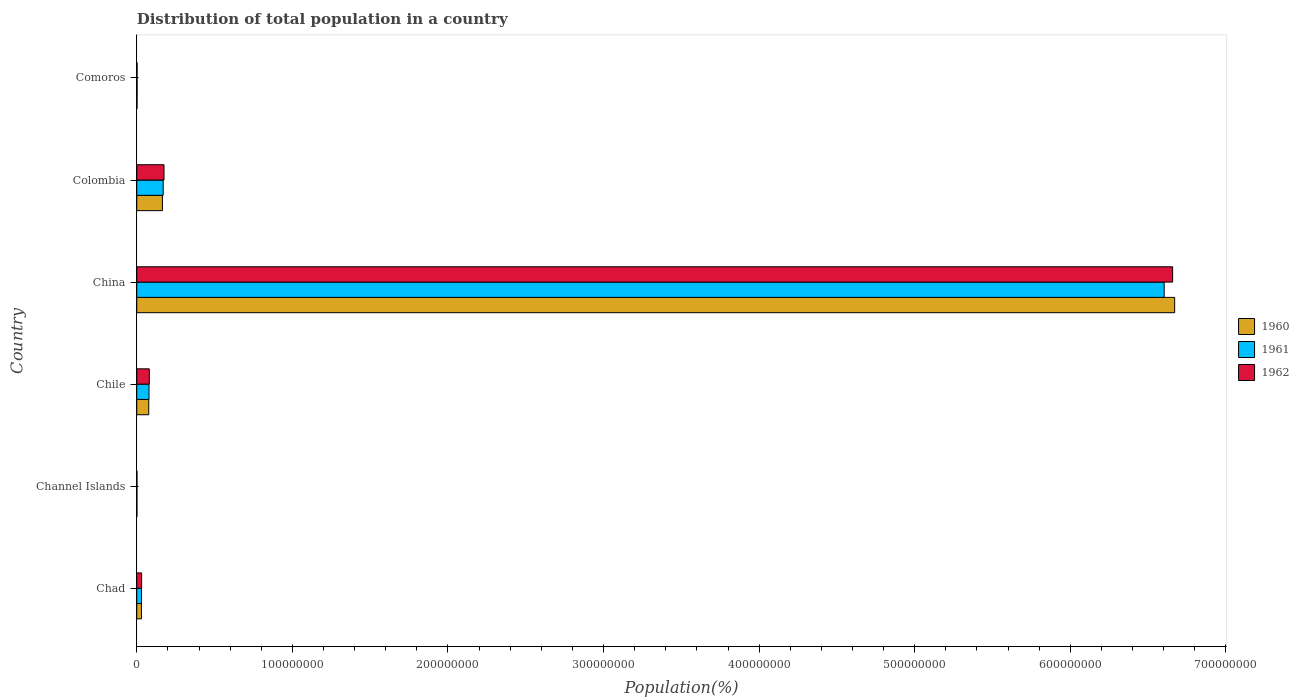Are the number of bars per tick equal to the number of legend labels?
Ensure brevity in your answer.  Yes. What is the label of the 2nd group of bars from the top?
Make the answer very short. Colombia. What is the population of in 1961 in Chad?
Offer a terse response. 3.06e+06. Across all countries, what is the maximum population of in 1960?
Give a very brief answer. 6.67e+08. Across all countries, what is the minimum population of in 1960?
Provide a succinct answer. 1.09e+05. In which country was the population of in 1962 maximum?
Offer a terse response. China. In which country was the population of in 1962 minimum?
Your answer should be compact. Channel Islands. What is the total population of in 1961 in the graph?
Provide a succinct answer. 6.89e+08. What is the difference between the population of in 1962 in Colombia and that in Comoros?
Provide a succinct answer. 1.73e+07. What is the difference between the population of in 1961 in Chile and the population of in 1962 in Channel Islands?
Keep it short and to the point. 7.76e+06. What is the average population of in 1962 per country?
Your answer should be very brief. 1.16e+08. What is the difference between the population of in 1962 and population of in 1960 in Chile?
Your answer should be very brief. 3.58e+05. In how many countries, is the population of in 1961 greater than 400000000 %?
Your response must be concise. 1. What is the ratio of the population of in 1961 in Chile to that in China?
Offer a terse response. 0.01. Is the population of in 1961 in Chile less than that in Comoros?
Make the answer very short. No. What is the difference between the highest and the second highest population of in 1960?
Provide a succinct answer. 6.51e+08. What is the difference between the highest and the lowest population of in 1960?
Make the answer very short. 6.67e+08. Is the sum of the population of in 1960 in Channel Islands and China greater than the maximum population of in 1962 across all countries?
Keep it short and to the point. Yes. What does the 1st bar from the bottom in Chad represents?
Make the answer very short. 1960. Is it the case that in every country, the sum of the population of in 1961 and population of in 1962 is greater than the population of in 1960?
Give a very brief answer. Yes. What is the difference between two consecutive major ticks on the X-axis?
Keep it short and to the point. 1.00e+08. How are the legend labels stacked?
Provide a succinct answer. Vertical. What is the title of the graph?
Ensure brevity in your answer.  Distribution of total population in a country. Does "1971" appear as one of the legend labels in the graph?
Ensure brevity in your answer.  No. What is the label or title of the X-axis?
Ensure brevity in your answer.  Population(%). What is the Population(%) in 1960 in Chad?
Provide a succinct answer. 3.00e+06. What is the Population(%) of 1961 in Chad?
Provide a short and direct response. 3.06e+06. What is the Population(%) of 1962 in Chad?
Keep it short and to the point. 3.12e+06. What is the Population(%) in 1960 in Channel Islands?
Provide a short and direct response. 1.09e+05. What is the Population(%) of 1961 in Channel Islands?
Offer a terse response. 1.10e+05. What is the Population(%) of 1962 in Channel Islands?
Your answer should be very brief. 1.11e+05. What is the Population(%) of 1960 in Chile?
Your answer should be compact. 7.70e+06. What is the Population(%) in 1961 in Chile?
Provide a succinct answer. 7.87e+06. What is the Population(%) of 1962 in Chile?
Offer a terse response. 8.05e+06. What is the Population(%) in 1960 in China?
Provide a succinct answer. 6.67e+08. What is the Population(%) in 1961 in China?
Your response must be concise. 6.60e+08. What is the Population(%) of 1962 in China?
Provide a short and direct response. 6.66e+08. What is the Population(%) of 1960 in Colombia?
Your answer should be compact. 1.65e+07. What is the Population(%) of 1961 in Colombia?
Provide a short and direct response. 1.70e+07. What is the Population(%) of 1962 in Colombia?
Ensure brevity in your answer.  1.75e+07. What is the Population(%) of 1960 in Comoros?
Provide a succinct answer. 1.89e+05. What is the Population(%) of 1961 in Comoros?
Provide a succinct answer. 1.92e+05. What is the Population(%) of 1962 in Comoros?
Ensure brevity in your answer.  1.95e+05. Across all countries, what is the maximum Population(%) of 1960?
Ensure brevity in your answer.  6.67e+08. Across all countries, what is the maximum Population(%) in 1961?
Provide a succinct answer. 6.60e+08. Across all countries, what is the maximum Population(%) in 1962?
Provide a succinct answer. 6.66e+08. Across all countries, what is the minimum Population(%) of 1960?
Ensure brevity in your answer.  1.09e+05. Across all countries, what is the minimum Population(%) of 1961?
Your answer should be compact. 1.10e+05. Across all countries, what is the minimum Population(%) in 1962?
Your response must be concise. 1.11e+05. What is the total Population(%) of 1960 in the graph?
Your response must be concise. 6.95e+08. What is the total Population(%) of 1961 in the graph?
Keep it short and to the point. 6.89e+08. What is the total Population(%) of 1962 in the graph?
Ensure brevity in your answer.  6.95e+08. What is the difference between the Population(%) of 1960 in Chad and that in Channel Islands?
Ensure brevity in your answer.  2.89e+06. What is the difference between the Population(%) of 1961 in Chad and that in Channel Islands?
Make the answer very short. 2.95e+06. What is the difference between the Population(%) of 1962 in Chad and that in Channel Islands?
Your answer should be compact. 3.01e+06. What is the difference between the Population(%) of 1960 in Chad and that in Chile?
Your answer should be very brief. -4.69e+06. What is the difference between the Population(%) of 1961 in Chad and that in Chile?
Your response must be concise. -4.81e+06. What is the difference between the Population(%) in 1962 in Chad and that in Chile?
Provide a short and direct response. -4.93e+06. What is the difference between the Population(%) of 1960 in Chad and that in China?
Your answer should be compact. -6.64e+08. What is the difference between the Population(%) in 1961 in Chad and that in China?
Offer a very short reply. -6.57e+08. What is the difference between the Population(%) of 1962 in Chad and that in China?
Your answer should be compact. -6.63e+08. What is the difference between the Population(%) in 1960 in Chad and that in Colombia?
Provide a succinct answer. -1.35e+07. What is the difference between the Population(%) in 1961 in Chad and that in Colombia?
Ensure brevity in your answer.  -1.39e+07. What is the difference between the Population(%) in 1962 in Chad and that in Colombia?
Provide a succinct answer. -1.44e+07. What is the difference between the Population(%) of 1960 in Chad and that in Comoros?
Provide a short and direct response. 2.81e+06. What is the difference between the Population(%) of 1961 in Chad and that in Comoros?
Provide a short and direct response. 2.87e+06. What is the difference between the Population(%) of 1962 in Chad and that in Comoros?
Your answer should be compact. 2.93e+06. What is the difference between the Population(%) in 1960 in Channel Islands and that in Chile?
Your response must be concise. -7.59e+06. What is the difference between the Population(%) of 1961 in Channel Islands and that in Chile?
Offer a terse response. -7.76e+06. What is the difference between the Population(%) of 1962 in Channel Islands and that in Chile?
Ensure brevity in your answer.  -7.94e+06. What is the difference between the Population(%) of 1960 in Channel Islands and that in China?
Make the answer very short. -6.67e+08. What is the difference between the Population(%) of 1961 in Channel Islands and that in China?
Provide a succinct answer. -6.60e+08. What is the difference between the Population(%) of 1962 in Channel Islands and that in China?
Keep it short and to the point. -6.66e+08. What is the difference between the Population(%) in 1960 in Channel Islands and that in Colombia?
Provide a short and direct response. -1.64e+07. What is the difference between the Population(%) in 1961 in Channel Islands and that in Colombia?
Give a very brief answer. -1.69e+07. What is the difference between the Population(%) in 1962 in Channel Islands and that in Colombia?
Offer a very short reply. -1.74e+07. What is the difference between the Population(%) of 1960 in Channel Islands and that in Comoros?
Make the answer very short. -7.93e+04. What is the difference between the Population(%) in 1961 in Channel Islands and that in Comoros?
Your response must be concise. -8.14e+04. What is the difference between the Population(%) of 1962 in Channel Islands and that in Comoros?
Make the answer very short. -8.35e+04. What is the difference between the Population(%) of 1960 in Chile and that in China?
Offer a very short reply. -6.59e+08. What is the difference between the Population(%) in 1961 in Chile and that in China?
Ensure brevity in your answer.  -6.52e+08. What is the difference between the Population(%) of 1962 in Chile and that in China?
Your answer should be very brief. -6.58e+08. What is the difference between the Population(%) of 1960 in Chile and that in Colombia?
Your response must be concise. -8.78e+06. What is the difference between the Population(%) of 1961 in Chile and that in Colombia?
Provide a succinct answer. -9.11e+06. What is the difference between the Population(%) of 1962 in Chile and that in Colombia?
Offer a very short reply. -9.45e+06. What is the difference between the Population(%) in 1960 in Chile and that in Comoros?
Your answer should be very brief. 7.51e+06. What is the difference between the Population(%) in 1961 in Chile and that in Comoros?
Make the answer very short. 7.68e+06. What is the difference between the Population(%) in 1962 in Chile and that in Comoros?
Your answer should be compact. 7.86e+06. What is the difference between the Population(%) of 1960 in China and that in Colombia?
Offer a terse response. 6.51e+08. What is the difference between the Population(%) of 1961 in China and that in Colombia?
Keep it short and to the point. 6.43e+08. What is the difference between the Population(%) of 1962 in China and that in Colombia?
Keep it short and to the point. 6.48e+08. What is the difference between the Population(%) in 1960 in China and that in Comoros?
Your response must be concise. 6.67e+08. What is the difference between the Population(%) of 1961 in China and that in Comoros?
Offer a very short reply. 6.60e+08. What is the difference between the Population(%) of 1962 in China and that in Comoros?
Make the answer very short. 6.66e+08. What is the difference between the Population(%) of 1960 in Colombia and that in Comoros?
Offer a very short reply. 1.63e+07. What is the difference between the Population(%) of 1961 in Colombia and that in Comoros?
Keep it short and to the point. 1.68e+07. What is the difference between the Population(%) in 1962 in Colombia and that in Comoros?
Make the answer very short. 1.73e+07. What is the difference between the Population(%) in 1960 in Chad and the Population(%) in 1961 in Channel Islands?
Your response must be concise. 2.89e+06. What is the difference between the Population(%) of 1960 in Chad and the Population(%) of 1962 in Channel Islands?
Your answer should be very brief. 2.89e+06. What is the difference between the Population(%) of 1961 in Chad and the Population(%) of 1962 in Channel Islands?
Provide a short and direct response. 2.95e+06. What is the difference between the Population(%) of 1960 in Chad and the Population(%) of 1961 in Chile?
Your response must be concise. -4.87e+06. What is the difference between the Population(%) of 1960 in Chad and the Population(%) of 1962 in Chile?
Ensure brevity in your answer.  -5.05e+06. What is the difference between the Population(%) in 1961 in Chad and the Population(%) in 1962 in Chile?
Offer a terse response. -4.99e+06. What is the difference between the Population(%) of 1960 in Chad and the Population(%) of 1961 in China?
Ensure brevity in your answer.  -6.57e+08. What is the difference between the Population(%) of 1960 in Chad and the Population(%) of 1962 in China?
Give a very brief answer. -6.63e+08. What is the difference between the Population(%) of 1961 in Chad and the Population(%) of 1962 in China?
Make the answer very short. -6.63e+08. What is the difference between the Population(%) in 1960 in Chad and the Population(%) in 1961 in Colombia?
Provide a succinct answer. -1.40e+07. What is the difference between the Population(%) in 1960 in Chad and the Population(%) in 1962 in Colombia?
Make the answer very short. -1.45e+07. What is the difference between the Population(%) in 1961 in Chad and the Population(%) in 1962 in Colombia?
Keep it short and to the point. -1.44e+07. What is the difference between the Population(%) of 1960 in Chad and the Population(%) of 1961 in Comoros?
Your response must be concise. 2.81e+06. What is the difference between the Population(%) in 1960 in Chad and the Population(%) in 1962 in Comoros?
Your answer should be very brief. 2.81e+06. What is the difference between the Population(%) of 1961 in Chad and the Population(%) of 1962 in Comoros?
Keep it short and to the point. 2.87e+06. What is the difference between the Population(%) of 1960 in Channel Islands and the Population(%) of 1961 in Chile?
Provide a succinct answer. -7.76e+06. What is the difference between the Population(%) in 1960 in Channel Islands and the Population(%) in 1962 in Chile?
Offer a terse response. -7.94e+06. What is the difference between the Population(%) of 1961 in Channel Islands and the Population(%) of 1962 in Chile?
Your response must be concise. -7.94e+06. What is the difference between the Population(%) of 1960 in Channel Islands and the Population(%) of 1961 in China?
Provide a succinct answer. -6.60e+08. What is the difference between the Population(%) in 1960 in Channel Islands and the Population(%) in 1962 in China?
Make the answer very short. -6.66e+08. What is the difference between the Population(%) in 1961 in Channel Islands and the Population(%) in 1962 in China?
Keep it short and to the point. -6.66e+08. What is the difference between the Population(%) of 1960 in Channel Islands and the Population(%) of 1961 in Colombia?
Offer a terse response. -1.69e+07. What is the difference between the Population(%) in 1960 in Channel Islands and the Population(%) in 1962 in Colombia?
Ensure brevity in your answer.  -1.74e+07. What is the difference between the Population(%) of 1961 in Channel Islands and the Population(%) of 1962 in Colombia?
Ensure brevity in your answer.  -1.74e+07. What is the difference between the Population(%) of 1960 in Channel Islands and the Population(%) of 1961 in Comoros?
Provide a short and direct response. -8.24e+04. What is the difference between the Population(%) of 1960 in Channel Islands and the Population(%) of 1962 in Comoros?
Give a very brief answer. -8.55e+04. What is the difference between the Population(%) of 1961 in Channel Islands and the Population(%) of 1962 in Comoros?
Provide a short and direct response. -8.46e+04. What is the difference between the Population(%) of 1960 in Chile and the Population(%) of 1961 in China?
Make the answer very short. -6.53e+08. What is the difference between the Population(%) of 1960 in Chile and the Population(%) of 1962 in China?
Your answer should be compact. -6.58e+08. What is the difference between the Population(%) of 1961 in Chile and the Population(%) of 1962 in China?
Your answer should be very brief. -6.58e+08. What is the difference between the Population(%) in 1960 in Chile and the Population(%) in 1961 in Colombia?
Your answer should be very brief. -9.29e+06. What is the difference between the Population(%) of 1960 in Chile and the Population(%) of 1962 in Colombia?
Your response must be concise. -9.80e+06. What is the difference between the Population(%) in 1961 in Chile and the Population(%) in 1962 in Colombia?
Keep it short and to the point. -9.63e+06. What is the difference between the Population(%) of 1960 in Chile and the Population(%) of 1961 in Comoros?
Provide a short and direct response. 7.50e+06. What is the difference between the Population(%) in 1960 in Chile and the Population(%) in 1962 in Comoros?
Ensure brevity in your answer.  7.50e+06. What is the difference between the Population(%) of 1961 in Chile and the Population(%) of 1962 in Comoros?
Keep it short and to the point. 7.68e+06. What is the difference between the Population(%) in 1960 in China and the Population(%) in 1961 in Colombia?
Your response must be concise. 6.50e+08. What is the difference between the Population(%) of 1960 in China and the Population(%) of 1962 in Colombia?
Your answer should be compact. 6.50e+08. What is the difference between the Population(%) of 1961 in China and the Population(%) of 1962 in Colombia?
Your answer should be compact. 6.43e+08. What is the difference between the Population(%) of 1960 in China and the Population(%) of 1961 in Comoros?
Provide a succinct answer. 6.67e+08. What is the difference between the Population(%) of 1960 in China and the Population(%) of 1962 in Comoros?
Your response must be concise. 6.67e+08. What is the difference between the Population(%) in 1961 in China and the Population(%) in 1962 in Comoros?
Give a very brief answer. 6.60e+08. What is the difference between the Population(%) in 1960 in Colombia and the Population(%) in 1961 in Comoros?
Offer a terse response. 1.63e+07. What is the difference between the Population(%) in 1960 in Colombia and the Population(%) in 1962 in Comoros?
Your answer should be very brief. 1.63e+07. What is the difference between the Population(%) of 1961 in Colombia and the Population(%) of 1962 in Comoros?
Keep it short and to the point. 1.68e+07. What is the average Population(%) in 1960 per country?
Your answer should be compact. 1.16e+08. What is the average Population(%) in 1961 per country?
Your answer should be compact. 1.15e+08. What is the average Population(%) in 1962 per country?
Make the answer very short. 1.16e+08. What is the difference between the Population(%) in 1960 and Population(%) in 1961 in Chad?
Provide a short and direct response. -5.88e+04. What is the difference between the Population(%) of 1960 and Population(%) of 1962 in Chad?
Ensure brevity in your answer.  -1.20e+05. What is the difference between the Population(%) in 1961 and Population(%) in 1962 in Chad?
Offer a very short reply. -6.09e+04. What is the difference between the Population(%) in 1960 and Population(%) in 1961 in Channel Islands?
Your response must be concise. -980. What is the difference between the Population(%) in 1960 and Population(%) in 1962 in Channel Islands?
Offer a very short reply. -2044. What is the difference between the Population(%) of 1961 and Population(%) of 1962 in Channel Islands?
Offer a terse response. -1064. What is the difference between the Population(%) of 1960 and Population(%) of 1961 in Chile?
Make the answer very short. -1.78e+05. What is the difference between the Population(%) of 1960 and Population(%) of 1962 in Chile?
Ensure brevity in your answer.  -3.58e+05. What is the difference between the Population(%) in 1961 and Population(%) in 1962 in Chile?
Ensure brevity in your answer.  -1.81e+05. What is the difference between the Population(%) of 1960 and Population(%) of 1961 in China?
Offer a terse response. 6.74e+06. What is the difference between the Population(%) in 1960 and Population(%) in 1962 in China?
Provide a short and direct response. 1.30e+06. What is the difference between the Population(%) of 1961 and Population(%) of 1962 in China?
Keep it short and to the point. -5.44e+06. What is the difference between the Population(%) of 1960 and Population(%) of 1961 in Colombia?
Ensure brevity in your answer.  -5.02e+05. What is the difference between the Population(%) of 1960 and Population(%) of 1962 in Colombia?
Give a very brief answer. -1.02e+06. What is the difference between the Population(%) of 1961 and Population(%) of 1962 in Colombia?
Provide a short and direct response. -5.18e+05. What is the difference between the Population(%) in 1960 and Population(%) in 1961 in Comoros?
Offer a very short reply. -3096. What is the difference between the Population(%) in 1960 and Population(%) in 1962 in Comoros?
Your answer should be compact. -6228. What is the difference between the Population(%) of 1961 and Population(%) of 1962 in Comoros?
Keep it short and to the point. -3132. What is the ratio of the Population(%) in 1960 in Chad to that in Channel Islands?
Keep it short and to the point. 27.44. What is the ratio of the Population(%) in 1961 in Chad to that in Channel Islands?
Ensure brevity in your answer.  27.73. What is the ratio of the Population(%) of 1962 in Chad to that in Channel Islands?
Give a very brief answer. 28.01. What is the ratio of the Population(%) of 1960 in Chad to that in Chile?
Your answer should be compact. 0.39. What is the ratio of the Population(%) in 1961 in Chad to that in Chile?
Make the answer very short. 0.39. What is the ratio of the Population(%) of 1962 in Chad to that in Chile?
Offer a terse response. 0.39. What is the ratio of the Population(%) in 1960 in Chad to that in China?
Your answer should be very brief. 0. What is the ratio of the Population(%) in 1961 in Chad to that in China?
Keep it short and to the point. 0. What is the ratio of the Population(%) of 1962 in Chad to that in China?
Your answer should be very brief. 0. What is the ratio of the Population(%) of 1960 in Chad to that in Colombia?
Your answer should be compact. 0.18. What is the ratio of the Population(%) of 1961 in Chad to that in Colombia?
Offer a terse response. 0.18. What is the ratio of the Population(%) of 1962 in Chad to that in Colombia?
Ensure brevity in your answer.  0.18. What is the ratio of the Population(%) of 1960 in Chad to that in Comoros?
Your answer should be very brief. 15.91. What is the ratio of the Population(%) of 1961 in Chad to that in Comoros?
Your answer should be compact. 15.96. What is the ratio of the Population(%) of 1962 in Chad to that in Comoros?
Offer a very short reply. 16.02. What is the ratio of the Population(%) in 1960 in Channel Islands to that in Chile?
Give a very brief answer. 0.01. What is the ratio of the Population(%) in 1961 in Channel Islands to that in Chile?
Keep it short and to the point. 0.01. What is the ratio of the Population(%) in 1962 in Channel Islands to that in Chile?
Give a very brief answer. 0.01. What is the ratio of the Population(%) in 1960 in Channel Islands to that in Colombia?
Provide a succinct answer. 0.01. What is the ratio of the Population(%) in 1961 in Channel Islands to that in Colombia?
Ensure brevity in your answer.  0.01. What is the ratio of the Population(%) of 1962 in Channel Islands to that in Colombia?
Provide a short and direct response. 0.01. What is the ratio of the Population(%) of 1960 in Channel Islands to that in Comoros?
Your answer should be compact. 0.58. What is the ratio of the Population(%) in 1961 in Channel Islands to that in Comoros?
Ensure brevity in your answer.  0.58. What is the ratio of the Population(%) of 1962 in Channel Islands to that in Comoros?
Make the answer very short. 0.57. What is the ratio of the Population(%) in 1960 in Chile to that in China?
Provide a succinct answer. 0.01. What is the ratio of the Population(%) in 1961 in Chile to that in China?
Make the answer very short. 0.01. What is the ratio of the Population(%) of 1962 in Chile to that in China?
Your response must be concise. 0.01. What is the ratio of the Population(%) in 1960 in Chile to that in Colombia?
Your answer should be very brief. 0.47. What is the ratio of the Population(%) in 1961 in Chile to that in Colombia?
Provide a short and direct response. 0.46. What is the ratio of the Population(%) in 1962 in Chile to that in Colombia?
Your answer should be compact. 0.46. What is the ratio of the Population(%) of 1960 in Chile to that in Comoros?
Offer a terse response. 40.78. What is the ratio of the Population(%) in 1961 in Chile to that in Comoros?
Provide a succinct answer. 41.04. What is the ratio of the Population(%) in 1962 in Chile to that in Comoros?
Offer a very short reply. 41.31. What is the ratio of the Population(%) of 1960 in China to that in Colombia?
Your answer should be very brief. 40.48. What is the ratio of the Population(%) in 1961 in China to that in Colombia?
Your answer should be compact. 38.88. What is the ratio of the Population(%) in 1962 in China to that in Colombia?
Provide a short and direct response. 38.04. What is the ratio of the Population(%) of 1960 in China to that in Comoros?
Provide a succinct answer. 3534.48. What is the ratio of the Population(%) in 1961 in China to that in Comoros?
Give a very brief answer. 3442.3. What is the ratio of the Population(%) in 1962 in China to that in Comoros?
Your answer should be very brief. 3414.91. What is the ratio of the Population(%) in 1960 in Colombia to that in Comoros?
Provide a succinct answer. 87.32. What is the ratio of the Population(%) in 1961 in Colombia to that in Comoros?
Provide a short and direct response. 88.53. What is the ratio of the Population(%) in 1962 in Colombia to that in Comoros?
Make the answer very short. 89.76. What is the difference between the highest and the second highest Population(%) in 1960?
Provide a succinct answer. 6.51e+08. What is the difference between the highest and the second highest Population(%) in 1961?
Offer a very short reply. 6.43e+08. What is the difference between the highest and the second highest Population(%) in 1962?
Keep it short and to the point. 6.48e+08. What is the difference between the highest and the lowest Population(%) of 1960?
Provide a succinct answer. 6.67e+08. What is the difference between the highest and the lowest Population(%) of 1961?
Offer a very short reply. 6.60e+08. What is the difference between the highest and the lowest Population(%) in 1962?
Provide a short and direct response. 6.66e+08. 